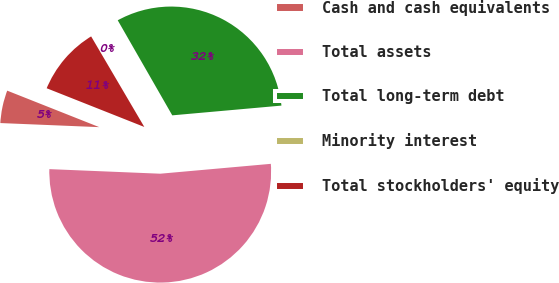Convert chart to OTSL. <chart><loc_0><loc_0><loc_500><loc_500><pie_chart><fcel>Cash and cash equivalents<fcel>Total assets<fcel>Total long-term debt<fcel>Minority interest<fcel>Total stockholders' equity<nl><fcel>5.35%<fcel>52.07%<fcel>31.87%<fcel>0.16%<fcel>10.54%<nl></chart> 